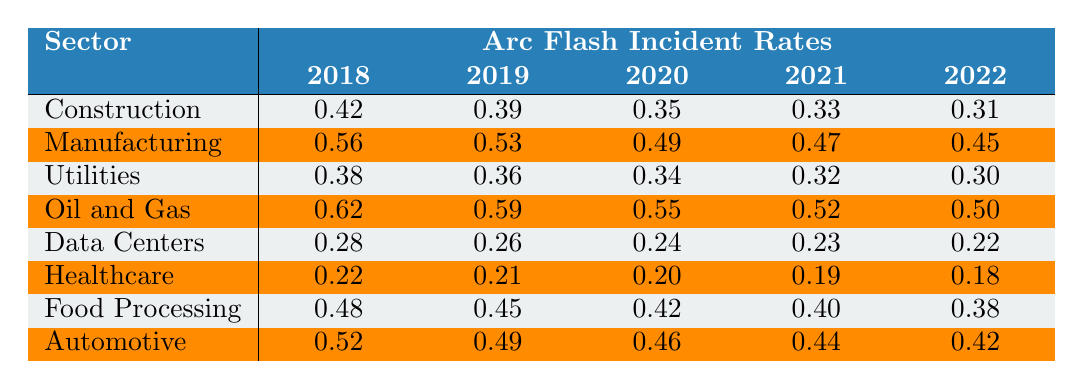What was the arc flash incident rate for the Manufacturing sector in 2020? According to the table, the incident rate for Manufacturing in 2020 is specifically listed as 0.49.
Answer: 0.49 Which sector had the highest arc flash incident rate in 2018? By examining the 2018 data, Oil and Gas shows the highest incident rate at 0.62 compared to other sectors.
Answer: Oil and Gas What is the average arc flash incident rate for Data Centers over the years provided? The incident rates for Data Centers from 2018 to 2022 are 0.28, 0.26, 0.24, 0.23, and 0.22. Summing these values gives 1.23; dividing by 5 results in an average of 0.246.
Answer: 0.246 Did the arc flash incident rate for Healthcare decrease from 2018 to 2022? The rates for Healthcare are 0.22 in 2018 and 0.18 in 2022, indicating a decrease over the years.
Answer: Yes What is the difference in the arc flash incident rate between the Construction and Utilities sectors in 2021? The incident rate for Construction in 2021 is 0.33, and for Utilities, it’s 0.32. The difference is 0.33 - 0.32 = 0.01.
Answer: 0.01 Can we say that the incident rate for the Automotive sector in 2022 was lower than that of the Food Processing sector? The rate for Automotive in 2022 is 0.42 while for Food Processing it is 0.38, which confirms that Automotive is higher.
Answer: No Which sector experienced the largest decrease in incident rate from 2018 to 2022? Looking at the data, Oil and Gas decreased from 0.62 to 0.50, a decrease of 0.12, which is the largest compared to other sectors.
Answer: Oil and Gas How do the incident rates of the Manufacturing sector in 2019 and 2020 compare? In 2019, the rate was 0.53, and in 2020, it was 0.49. The Manufacturing sector saw a decrease of 0.04 from 2019 to 2020.
Answer: Decreased by 0.04 What was the trend in the arc flash incident rates for the Healthcare sector from 2018 to 2022? The rates for Healthcare declined from 0.22 in 2018 to 0.18 in 2022, indicating a consistent downward trend over these years.
Answer: Decrease Is the incident rate for Utilities in 2021 higher than that of Data Centers in the same year? The data shows Utilities at 0.32 and Data Centers at 0.23 in 2021, confirming that Utilities has a higher incident rate.
Answer: Yes 